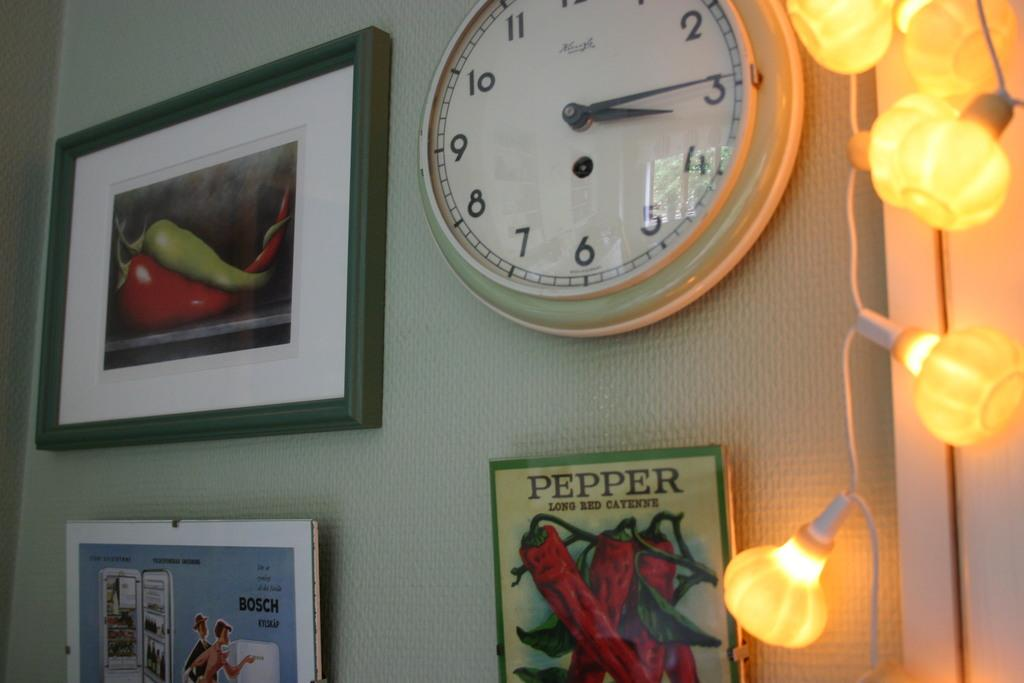<image>
Relay a brief, clear account of the picture shown. White clock that is above a PEPPER poster. 